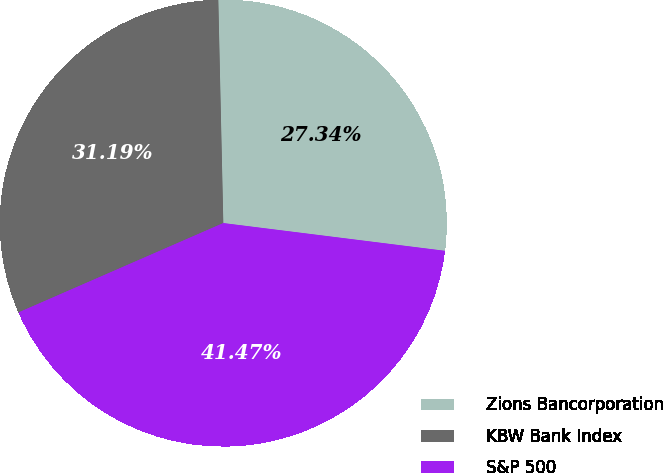Convert chart. <chart><loc_0><loc_0><loc_500><loc_500><pie_chart><fcel>Zions Bancorporation<fcel>KBW Bank Index<fcel>S&P 500<nl><fcel>27.34%<fcel>31.19%<fcel>41.47%<nl></chart> 